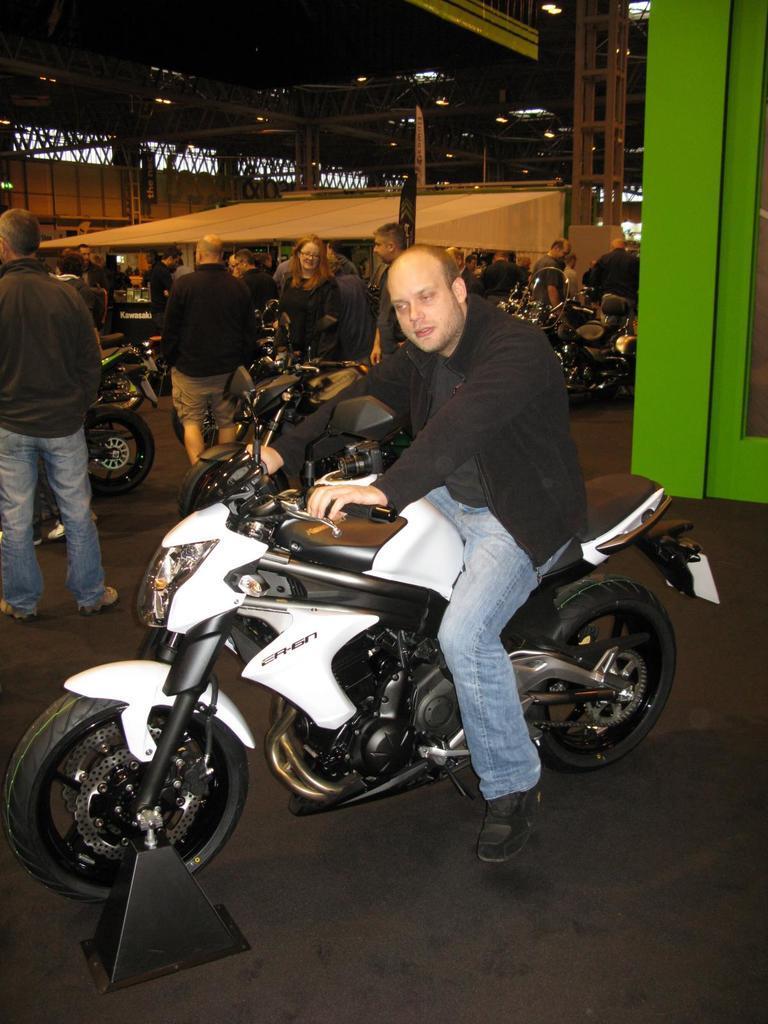How would you summarize this image in a sentence or two? This is a person sitting on the motorbike. I can see groups of people standing. These are the motorbikes. This looks like a shelter, which is built with the iron pillars. 